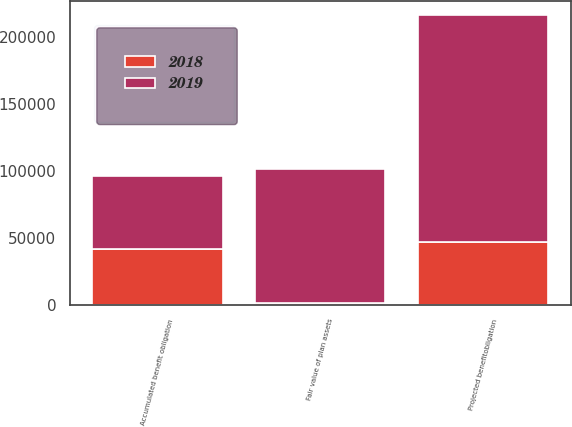Convert chart. <chart><loc_0><loc_0><loc_500><loc_500><stacked_bar_chart><ecel><fcel>Projected benefitobligation<fcel>Fair value of plan assets<fcel>Accumulated benefit obligation<nl><fcel>2019<fcel>169648<fcel>99939<fcel>54318<nl><fcel>2018<fcel>46626<fcel>1174<fcel>41701<nl></chart> 